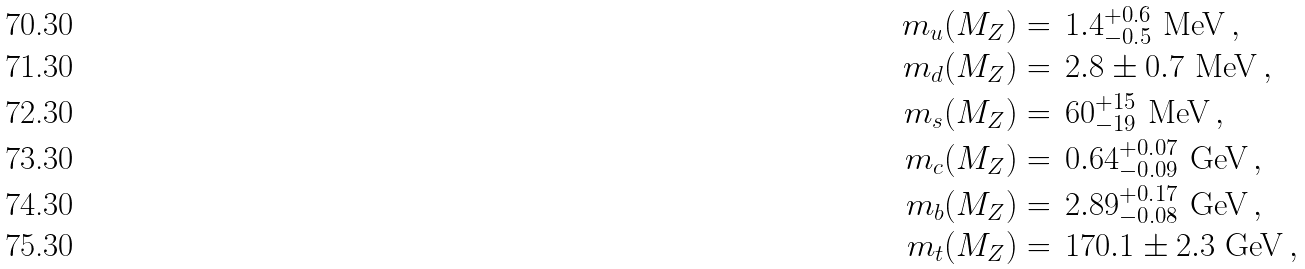Convert formula to latex. <formula><loc_0><loc_0><loc_500><loc_500>m _ { u } ( M _ { Z } ) & = \, 1 . 4 _ { - 0 . 5 } ^ { + 0 . 6 } \text { MeV} \, , \\ m _ { d } ( M _ { Z } ) & = \, 2 . 8 \pm { 0 . 7 } \text { MeV} \, , \\ m _ { s } ( M _ { Z } ) & = \, 6 0 _ { - 1 9 } ^ { + 1 5 } \text { MeV} \, , \\ m _ { c } ( M _ { Z } ) & = \, 0 . 6 4 _ { - 0 . 0 9 } ^ { + 0 . 0 7 } \text { GeV} \, , \\ m _ { b } ( M _ { Z } ) & = \, 2 . 8 9 _ { - 0 . 0 8 } ^ { + 0 . 1 7 } \text { GeV} \, , \\ m _ { t } ( M _ { Z } ) & = \, 1 7 0 . 1 \pm { 2 . 3 } \text { GeV} \, ,</formula> 